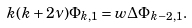<formula> <loc_0><loc_0><loc_500><loc_500>k ( k + 2 \nu ) \Phi _ { k , 1 } = w \Delta \Phi _ { k - 2 , 1 } .</formula> 